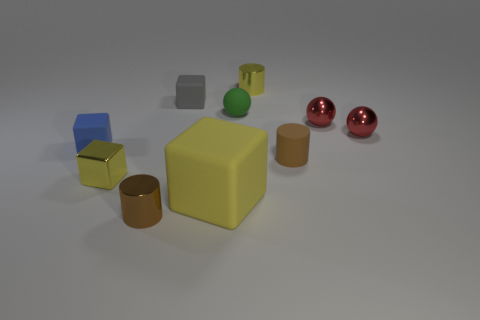Subtract all tiny green balls. How many balls are left? 2 Subtract all gray cubes. How many cubes are left? 3 Subtract 2 blocks. How many blocks are left? 2 Subtract all red cubes. Subtract all purple cylinders. How many cubes are left? 4 Subtract all cylinders. How many objects are left? 7 Add 6 yellow shiny objects. How many yellow shiny objects are left? 8 Add 8 tiny blue rubber objects. How many tiny blue rubber objects exist? 9 Subtract 1 brown cylinders. How many objects are left? 9 Subtract all tiny balls. Subtract all tiny matte cylinders. How many objects are left? 6 